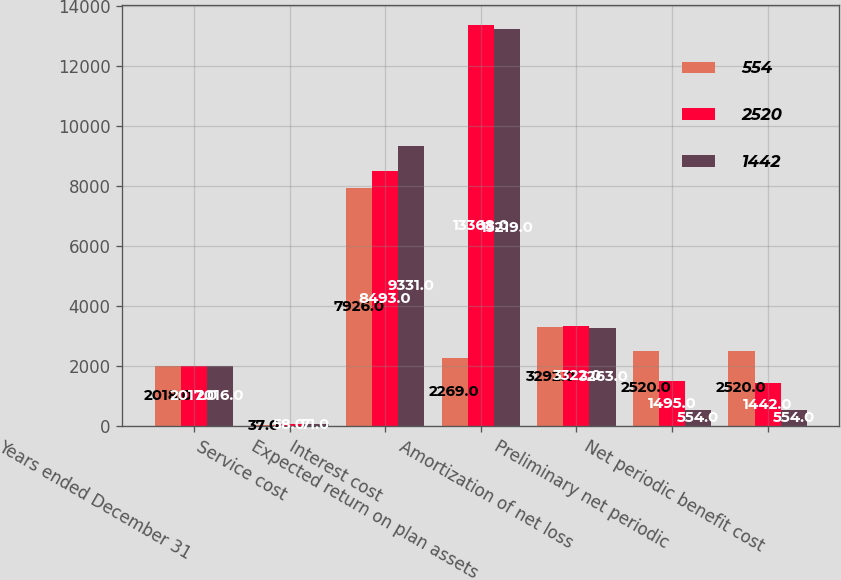Convert chart to OTSL. <chart><loc_0><loc_0><loc_500><loc_500><stacked_bar_chart><ecel><fcel>Years ended December 31<fcel>Service cost<fcel>Interest cost<fcel>Expected return on plan assets<fcel>Amortization of net loss<fcel>Preliminary net periodic<fcel>Net periodic benefit cost<nl><fcel>554<fcel>2018<fcel>37<fcel>7926<fcel>2269<fcel>3292<fcel>2520<fcel>2520<nl><fcel>2520<fcel>2017<fcel>58<fcel>8493<fcel>13368<fcel>3322<fcel>1495<fcel>1442<nl><fcel>1442<fcel>2016<fcel>71<fcel>9331<fcel>13219<fcel>3263<fcel>554<fcel>554<nl></chart> 